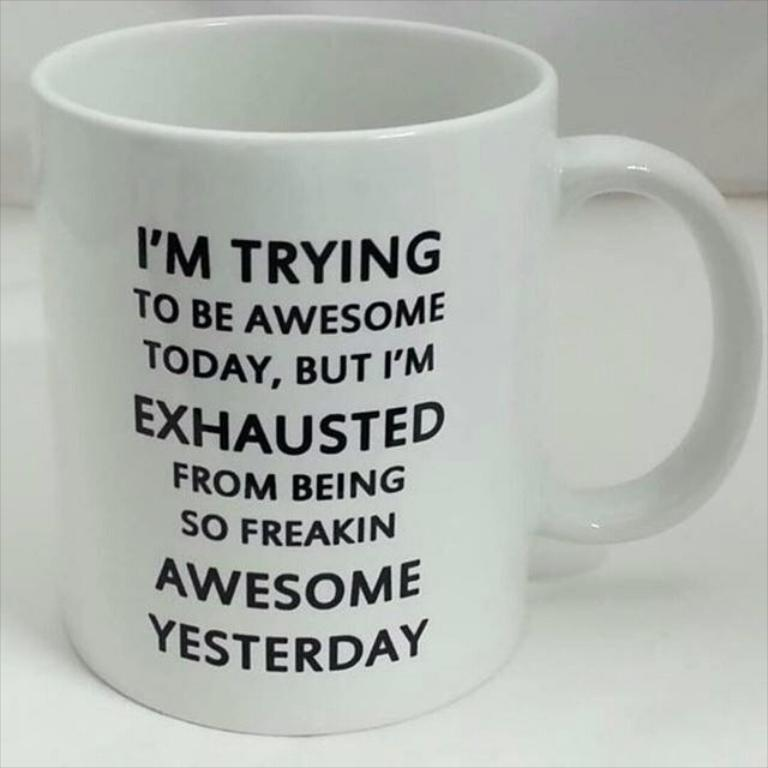<image>
Create a compact narrative representing the image presented. A white coffee mug has a humorous line about being awesome. 